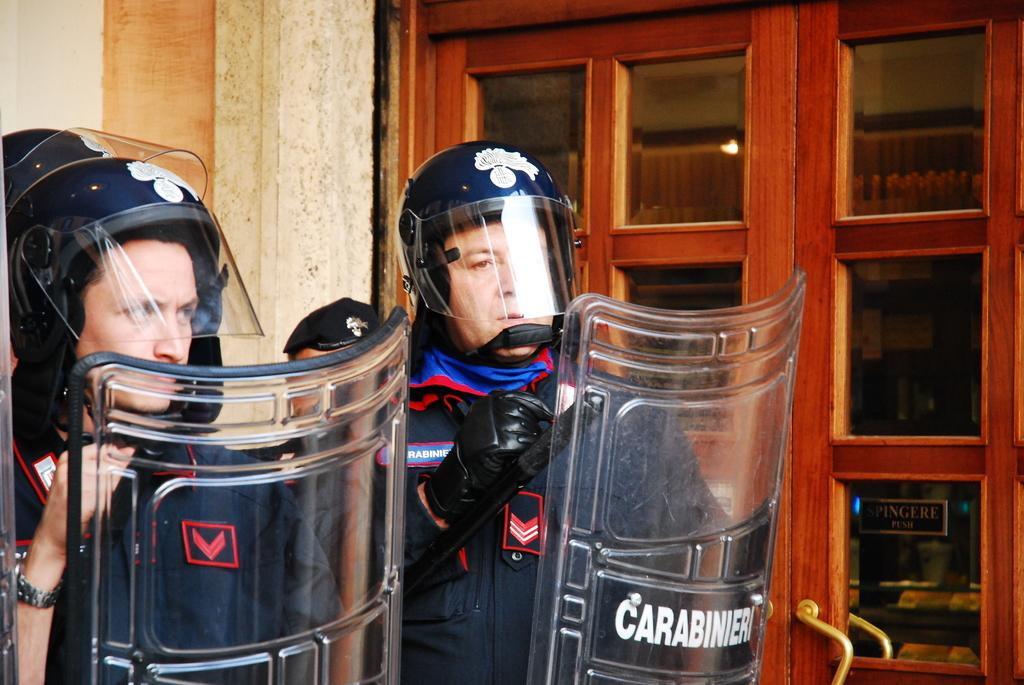How many people are in the image? There are two persons in the image. What are the persons wearing? The persons are wearing uniforms and helmets. What are the persons holding in their hands? The persons are holding shields in their hands. What can be seen in the background of the image? There are wooden glass doors and a wall visible in the background of the image. Can you see any islands in the image? No, there are no islands present in the image. What type of bread is being used to rake the floor in the image? There is no bread or raking activity depicted in the image. 